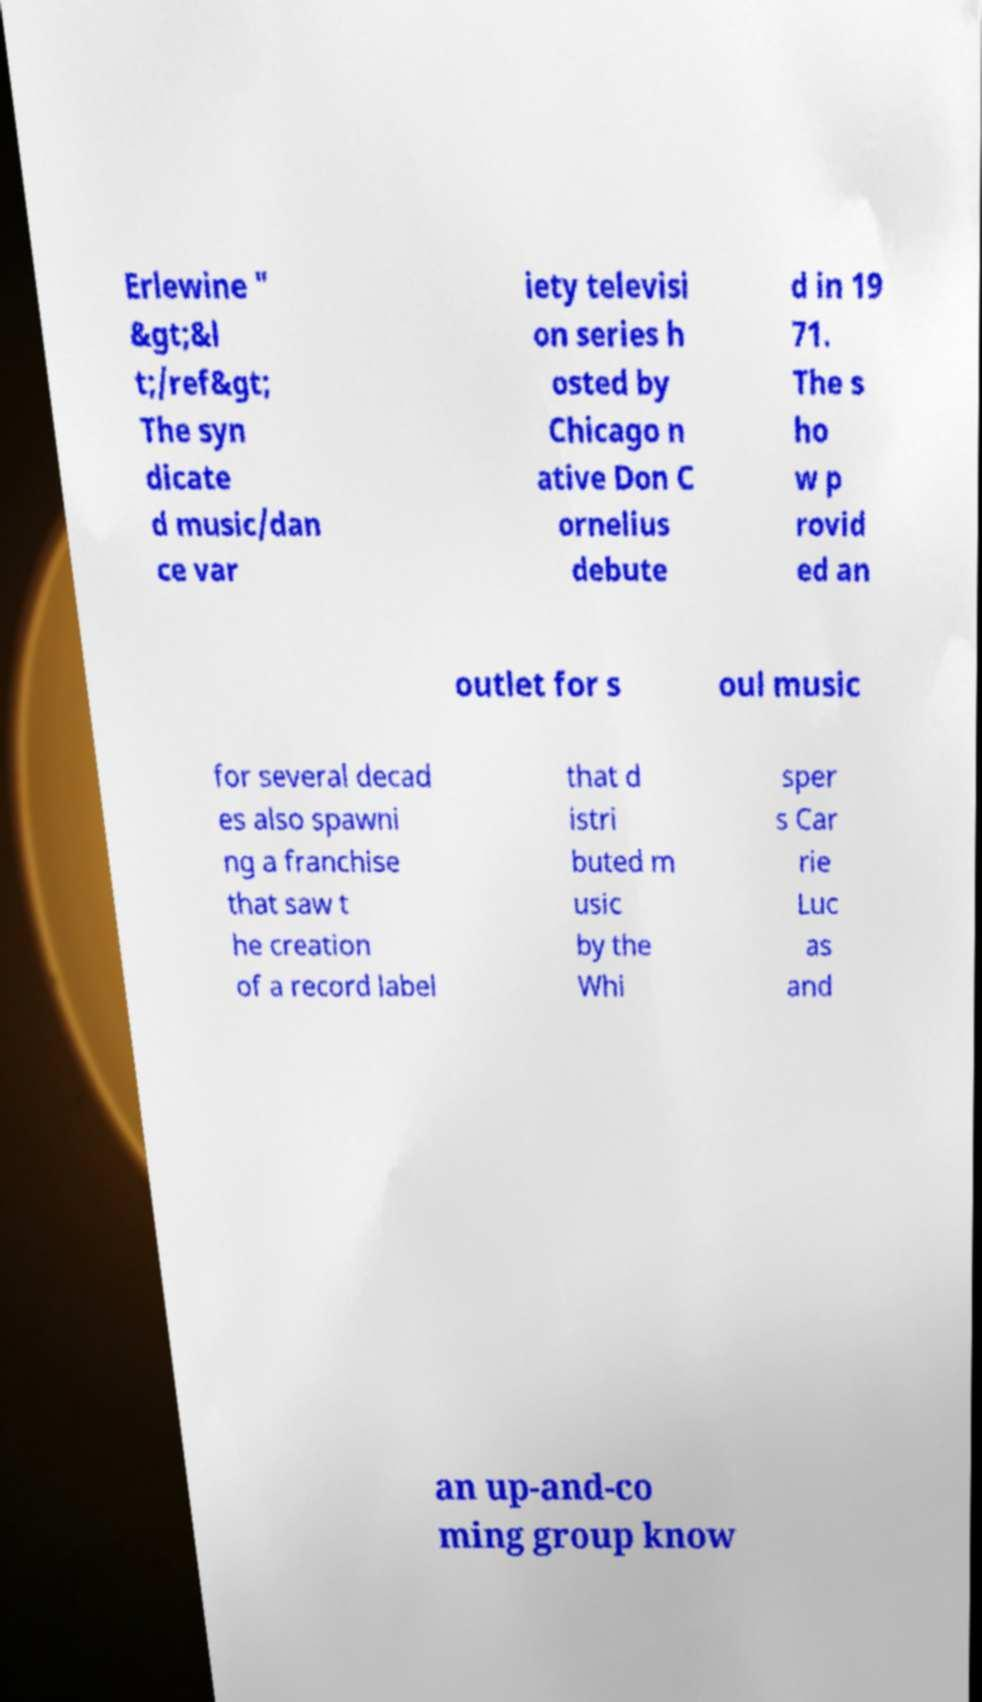What messages or text are displayed in this image? I need them in a readable, typed format. Erlewine " &gt;&l t;/ref&gt; The syn dicate d music/dan ce var iety televisi on series h osted by Chicago n ative Don C ornelius debute d in 19 71. The s ho w p rovid ed an outlet for s oul music for several decad es also spawni ng a franchise that saw t he creation of a record label that d istri buted m usic by the Whi sper s Car rie Luc as and an up-and-co ming group know 